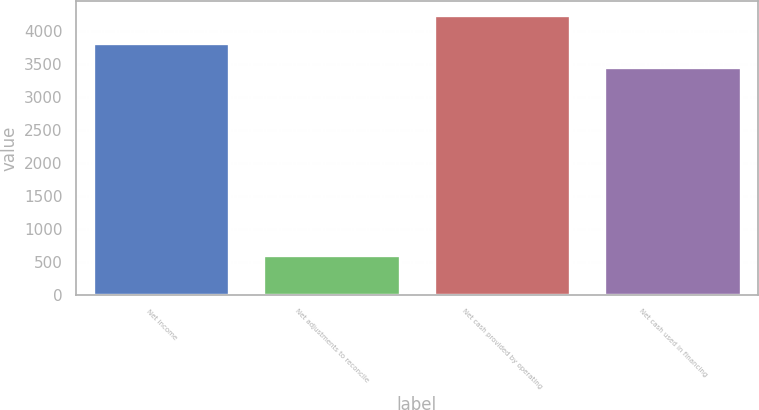<chart> <loc_0><loc_0><loc_500><loc_500><bar_chart><fcel>Net income<fcel>Net adjustments to reconcile<fcel>Net cash provided by operating<fcel>Net cash used in financing<nl><fcel>3804.2<fcel>609<fcel>4231<fcel>3442<nl></chart> 